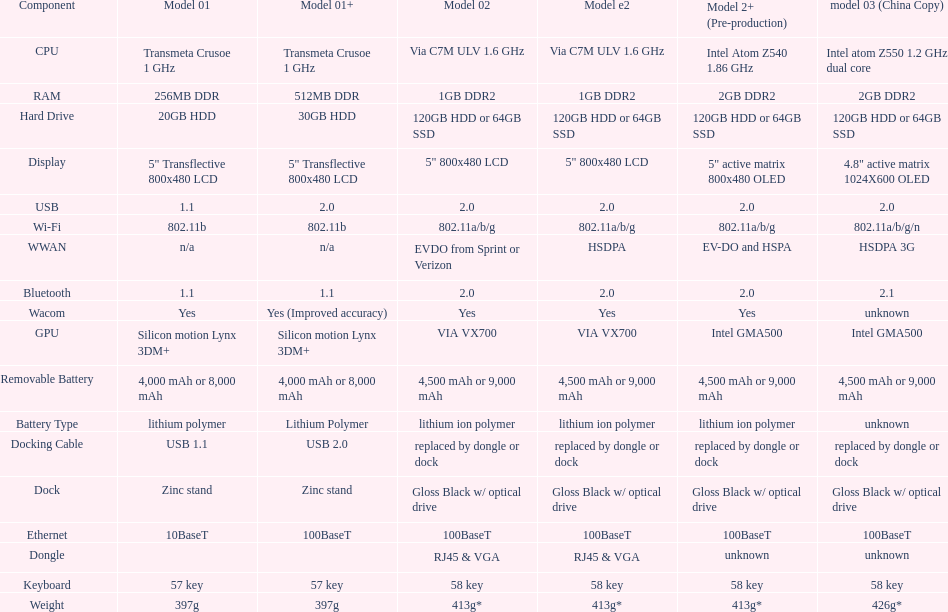Which model provides a larger hard drive: model 01 or model 02? Model 02. 